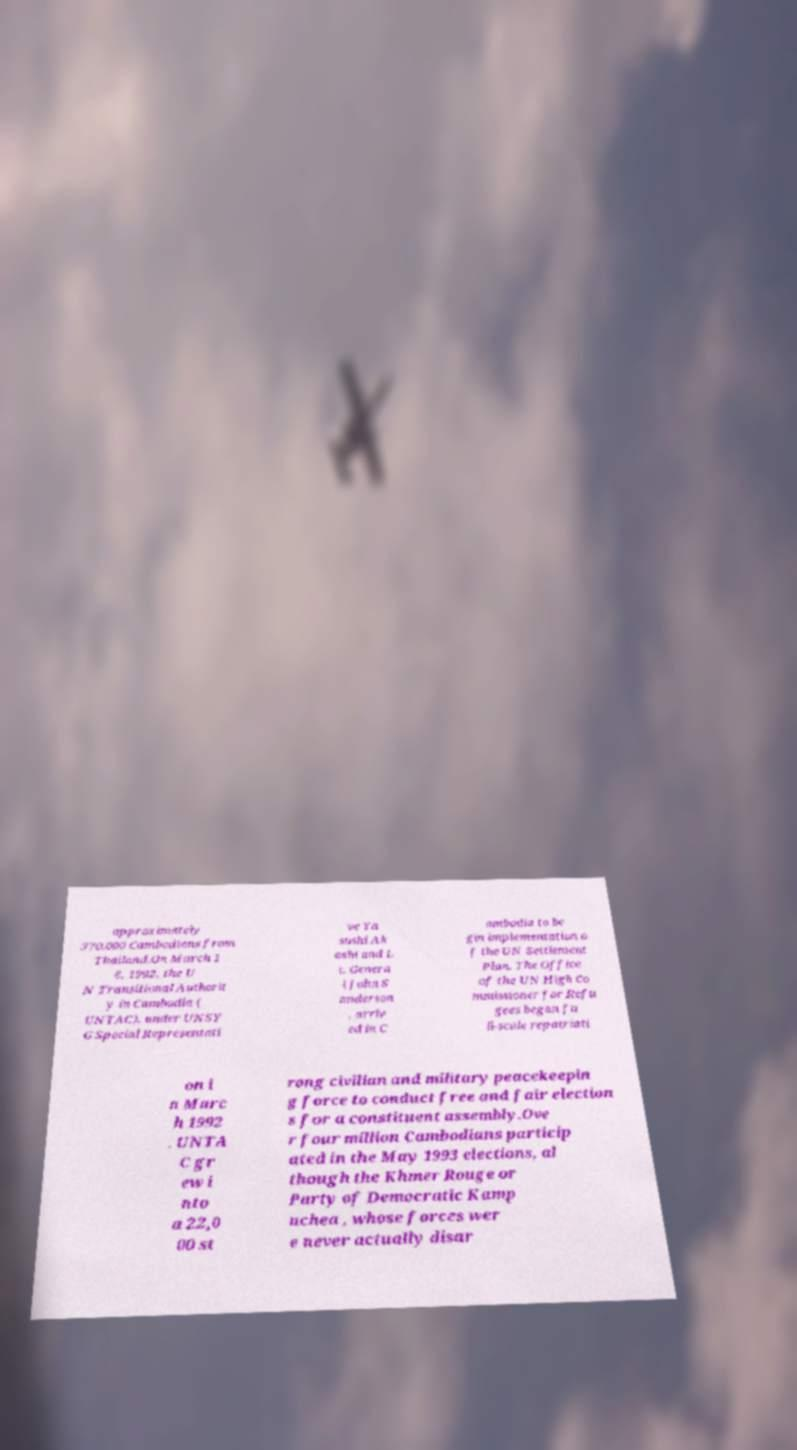Could you extract and type out the text from this image? approximately 370,000 Cambodians from Thailand.On March 1 6, 1992, the U N Transitional Authorit y in Cambodia ( UNTAC), under UNSY G Special Representati ve Ya sushi Ak ashi and L t. Genera l John S anderson , arriv ed in C ambodia to be gin implementation o f the UN Settlement Plan. The Office of the UN High Co mmissioner for Refu gees began fu ll-scale repatriati on i n Marc h 1992 . UNTA C gr ew i nto a 22,0 00 st rong civilian and military peacekeepin g force to conduct free and fair election s for a constituent assembly.Ove r four million Cambodians particip ated in the May 1993 elections, al though the Khmer Rouge or Party of Democratic Kamp uchea , whose forces wer e never actually disar 